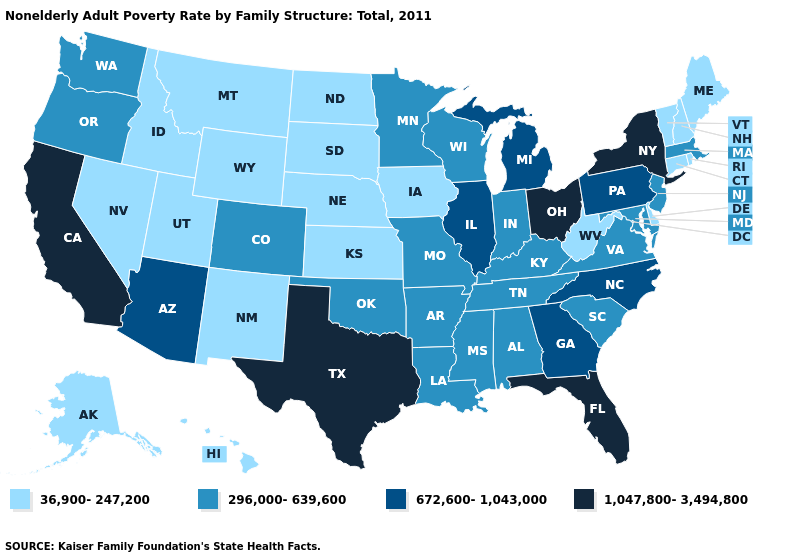What is the value of Vermont?
Keep it brief. 36,900-247,200. Name the states that have a value in the range 672,600-1,043,000?
Give a very brief answer. Arizona, Georgia, Illinois, Michigan, North Carolina, Pennsylvania. Does Oregon have the lowest value in the USA?
Short answer required. No. What is the lowest value in the USA?
Be succinct. 36,900-247,200. Which states have the lowest value in the West?
Give a very brief answer. Alaska, Hawaii, Idaho, Montana, Nevada, New Mexico, Utah, Wyoming. Name the states that have a value in the range 36,900-247,200?
Be succinct. Alaska, Connecticut, Delaware, Hawaii, Idaho, Iowa, Kansas, Maine, Montana, Nebraska, Nevada, New Hampshire, New Mexico, North Dakota, Rhode Island, South Dakota, Utah, Vermont, West Virginia, Wyoming. Is the legend a continuous bar?
Concise answer only. No. What is the value of Illinois?
Concise answer only. 672,600-1,043,000. Name the states that have a value in the range 296,000-639,600?
Short answer required. Alabama, Arkansas, Colorado, Indiana, Kentucky, Louisiana, Maryland, Massachusetts, Minnesota, Mississippi, Missouri, New Jersey, Oklahoma, Oregon, South Carolina, Tennessee, Virginia, Washington, Wisconsin. Does West Virginia have the lowest value in the South?
Concise answer only. Yes. What is the value of Missouri?
Answer briefly. 296,000-639,600. Which states have the lowest value in the USA?
Give a very brief answer. Alaska, Connecticut, Delaware, Hawaii, Idaho, Iowa, Kansas, Maine, Montana, Nebraska, Nevada, New Hampshire, New Mexico, North Dakota, Rhode Island, South Dakota, Utah, Vermont, West Virginia, Wyoming. Name the states that have a value in the range 36,900-247,200?
Answer briefly. Alaska, Connecticut, Delaware, Hawaii, Idaho, Iowa, Kansas, Maine, Montana, Nebraska, Nevada, New Hampshire, New Mexico, North Dakota, Rhode Island, South Dakota, Utah, Vermont, West Virginia, Wyoming. Does Mississippi have the highest value in the USA?
Give a very brief answer. No. What is the value of Nebraska?
Be succinct. 36,900-247,200. 